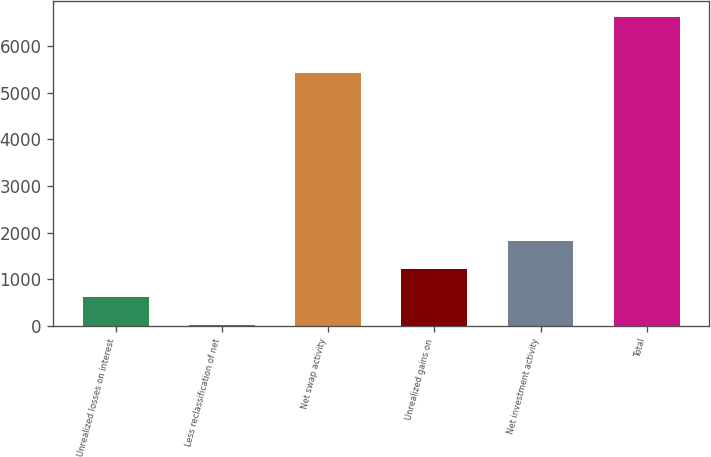Convert chart. <chart><loc_0><loc_0><loc_500><loc_500><bar_chart><fcel>Unrealized losses on interest<fcel>Less reclassification of net<fcel>Net swap activity<fcel>Unrealized gains on<fcel>Net investment activity<fcel>Total<nl><fcel>616.8<fcel>13<fcel>5423<fcel>1220.6<fcel>1824.4<fcel>6630.6<nl></chart> 